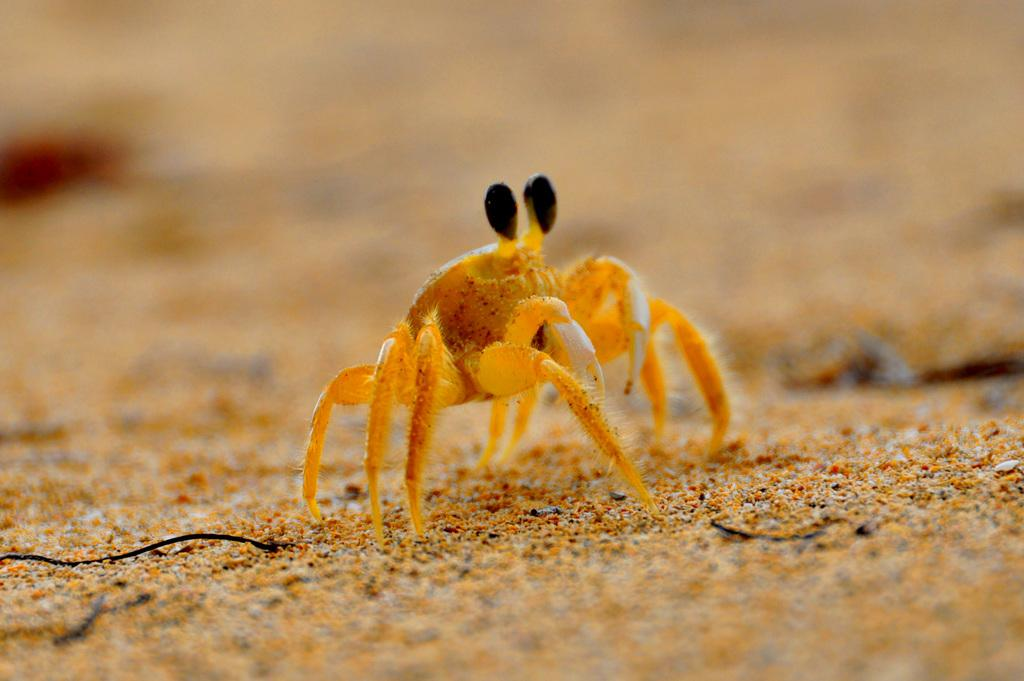What is present on the ground in the image? There is an insect on the ground in the image. Can you describe the background of the image? The background of the image is blurry. What type of eggnog can be seen on the hill in the image? There is no eggnog or hill present in the image; it features an insect on the ground with a blurry background. 